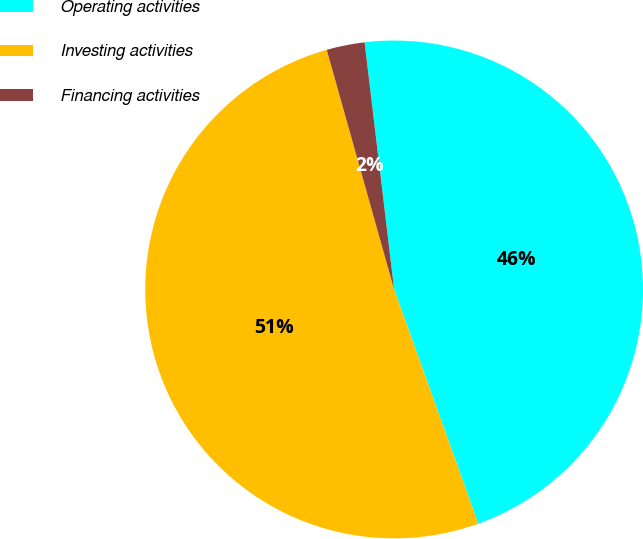<chart> <loc_0><loc_0><loc_500><loc_500><pie_chart><fcel>Operating activities<fcel>Investing activities<fcel>Financing activities<nl><fcel>46.41%<fcel>51.12%<fcel>2.47%<nl></chart> 